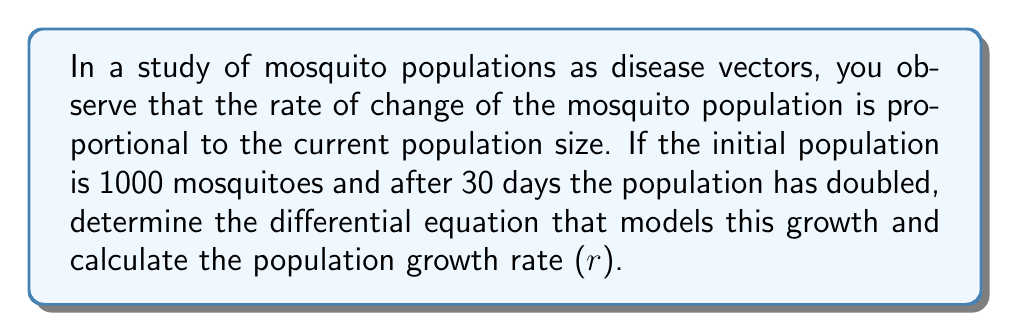What is the answer to this math problem? Let's approach this step-by-step:

1) Let $P(t)$ be the mosquito population at time $t$ (in days).

2) Given that the rate of change is proportional to the current population, we can write the differential equation:

   $$\frac{dP}{dt} = rP$$

   where $r$ is the growth rate we need to find.

3) The solution to this differential equation is:

   $$P(t) = P_0e^{rt}$$

   where $P_0$ is the initial population.

4) We're given two pieces of information:
   - $P_0 = 1000$ (initial population)
   - $P(30) = 2000$ (population doubled after 30 days)

5) Let's substitute these into our solution equation:

   $$2000 = 1000e^{30r}$$

6) Simplify:

   $$2 = e^{30r}$$

7) Take the natural log of both sides:

   $$\ln(2) = 30r$$

8) Solve for $r$:

   $$r = \frac{\ln(2)}{30} \approx 0.0231$$

This means the population grows at about 2.31% per day.

9) The final differential equation that models this growth is:

   $$\frac{dP}{dt} = 0.0231P$$
Answer: The differential equation is $\frac{dP}{dt} = 0.0231P$, and the growth rate $r \approx 0.0231$ or about 2.31% per day. 